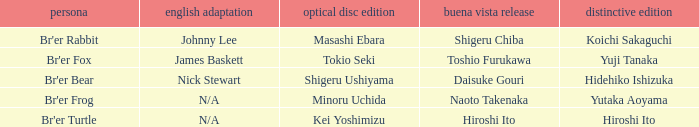Who is the buena vista edidtion where special edition is koichi sakaguchi? Shigeru Chiba. Can you give me this table as a dict? {'header': ['persona', 'english adaptation', 'optical disc edition', 'buena vista release', 'distinctive edition'], 'rows': [["Br'er Rabbit", 'Johnny Lee', 'Masashi Ebara', 'Shigeru Chiba', 'Koichi Sakaguchi'], ["Br'er Fox", 'James Baskett', 'Tokio Seki', 'Toshio Furukawa', 'Yuji Tanaka'], ["Br'er Bear", 'Nick Stewart', 'Shigeru Ushiyama', 'Daisuke Gouri', 'Hidehiko Ishizuka'], ["Br'er Frog", 'N/A', 'Minoru Uchida', 'Naoto Takenaka', 'Yutaka Aoyama'], ["Br'er Turtle", 'N/A', 'Kei Yoshimizu', 'Hiroshi Ito', 'Hiroshi Ito']]} 